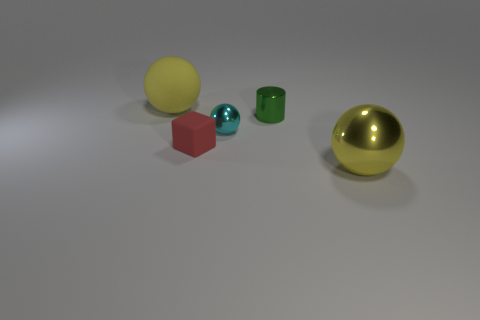Do the ball right of the cyan metallic thing and the tiny matte thing have the same size?
Ensure brevity in your answer.  No. There is a green thing that is the same size as the cyan metal object; what is it made of?
Your response must be concise. Metal. There is a small metallic object that is in front of the tiny shiny thing behind the small cyan shiny sphere; is there a big object behind it?
Keep it short and to the point. Yes. Are there any other things that are the same shape as the small matte object?
Offer a terse response. No. Does the large object behind the tiny sphere have the same color as the big thing to the right of the big rubber sphere?
Your answer should be compact. Yes. Is there a yellow rubber sphere?
Your answer should be compact. Yes. There is a large thing that is the same color as the big shiny sphere; what is its material?
Provide a succinct answer. Rubber. What size is the yellow sphere that is to the right of the big yellow ball to the left of the yellow shiny thing that is to the right of the small green cylinder?
Make the answer very short. Large. There is a small red rubber thing; is its shape the same as the metal object in front of the cyan metal object?
Make the answer very short. No. Are there any large spheres of the same color as the big metal object?
Offer a terse response. Yes. 